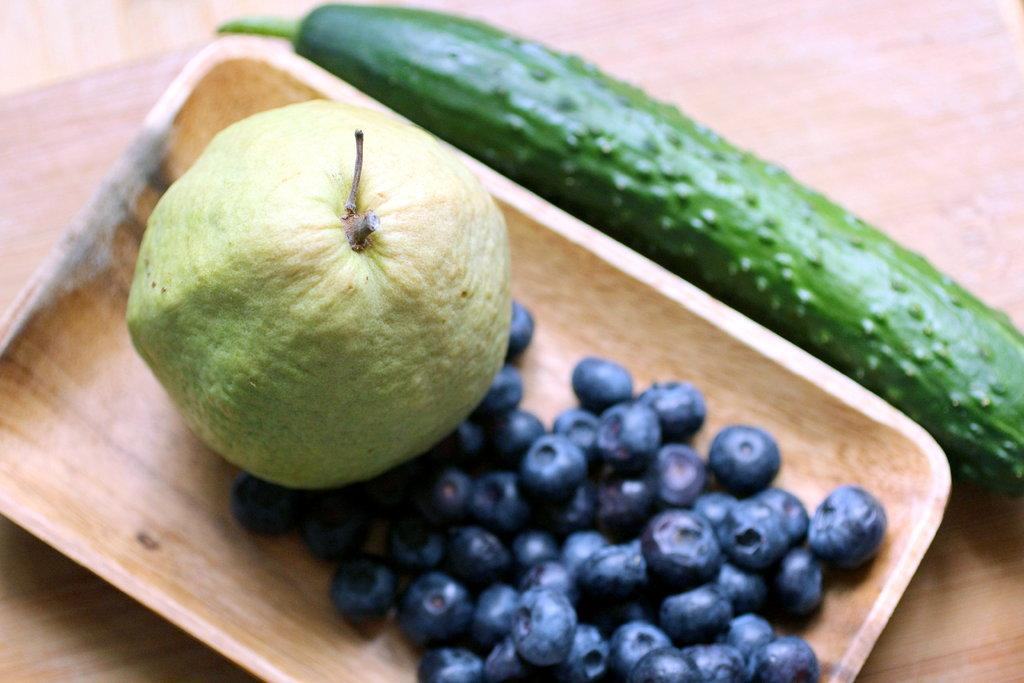What object is located in the center of the image? There is a wooden tray in the center of the image. What is on the wooden tray? The wooden tray contains a guava and black grapes. Are there any other fruits or vegetables in the image? Yes, there is a cucumber in the image. What type of apparel is the guava wearing in the image? The guava is not wearing any apparel in the image, as it is a fruit and not a person. How many days are represented by the plate in the image? There is no plate present in the image, and therefore no representation of days or weeks. 